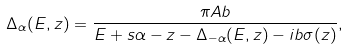<formula> <loc_0><loc_0><loc_500><loc_500>\Delta _ { \alpha } ( E , z ) = \frac { \pi A b } { E + s \alpha - z - \Delta _ { - \alpha } ( E , z ) - i b \sigma ( z ) } ,</formula> 